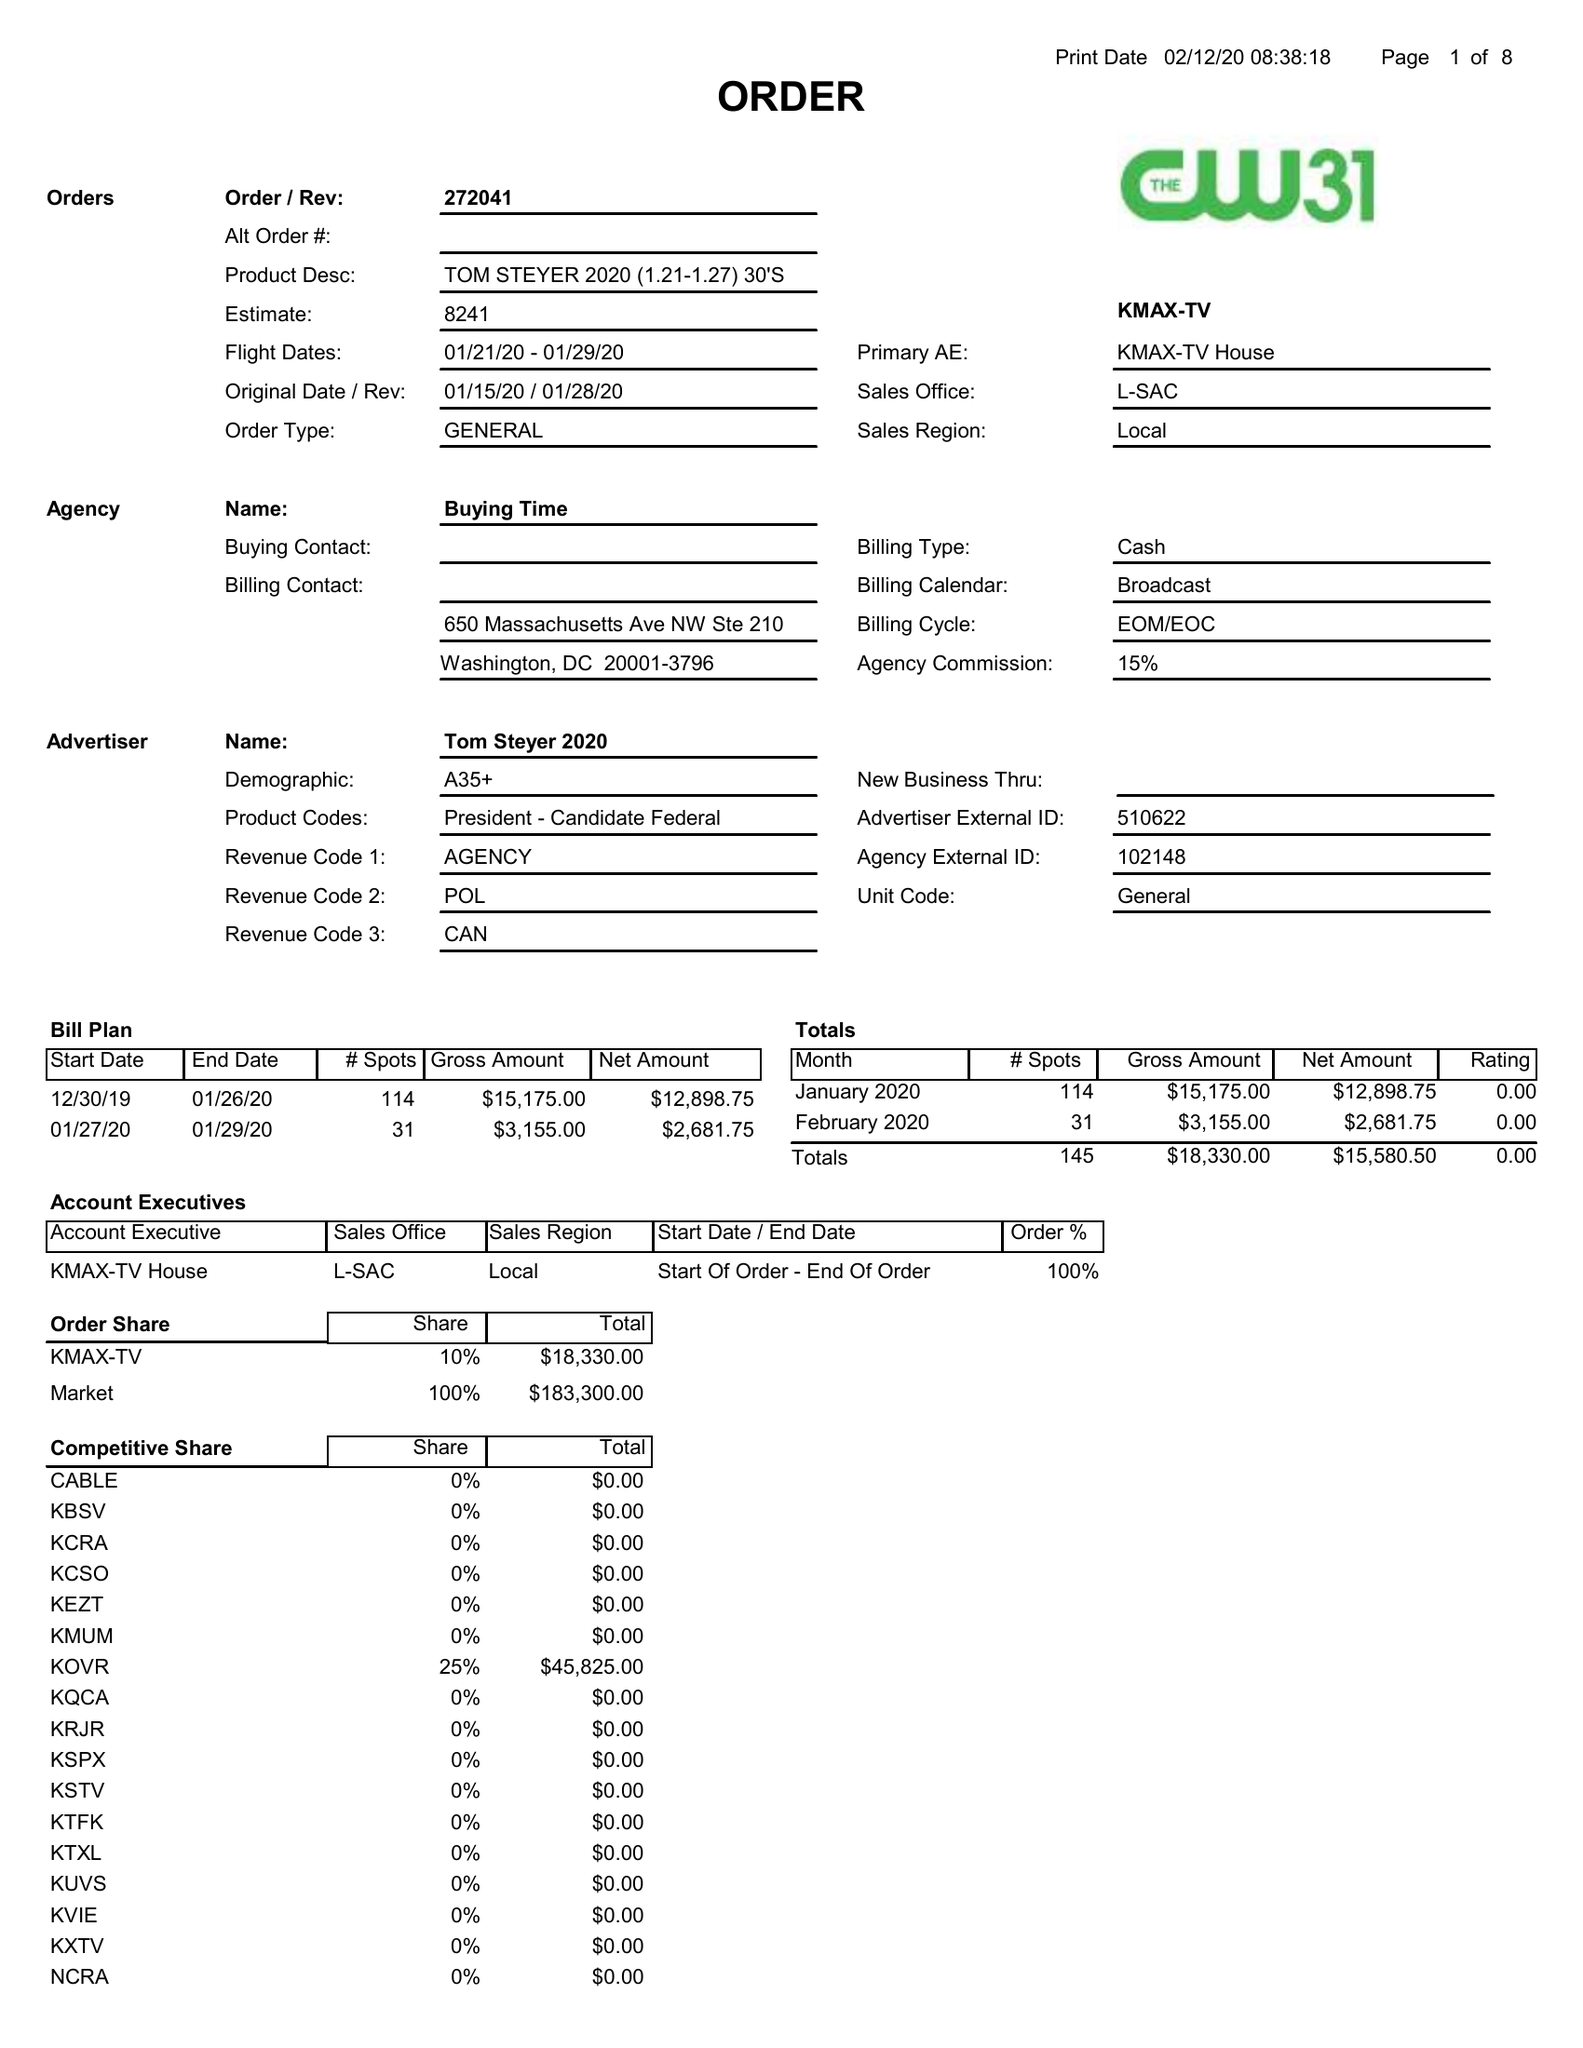What is the value for the gross_amount?
Answer the question using a single word or phrase. 18330.00 